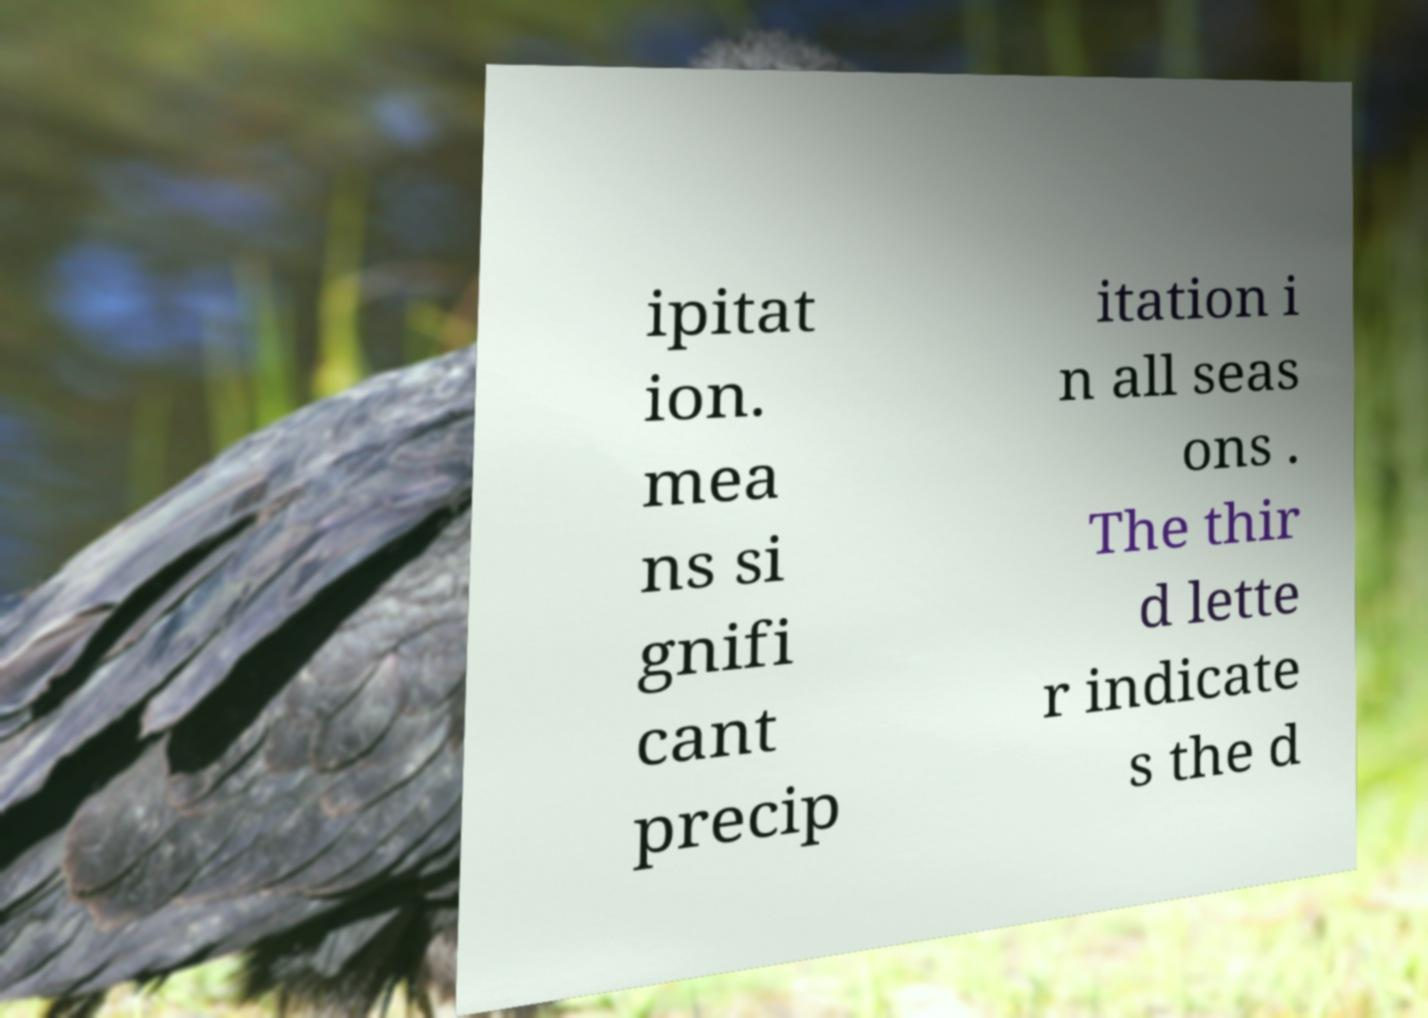What messages or text are displayed in this image? I need them in a readable, typed format. ipitat ion. mea ns si gnifi cant precip itation i n all seas ons . The thir d lette r indicate s the d 